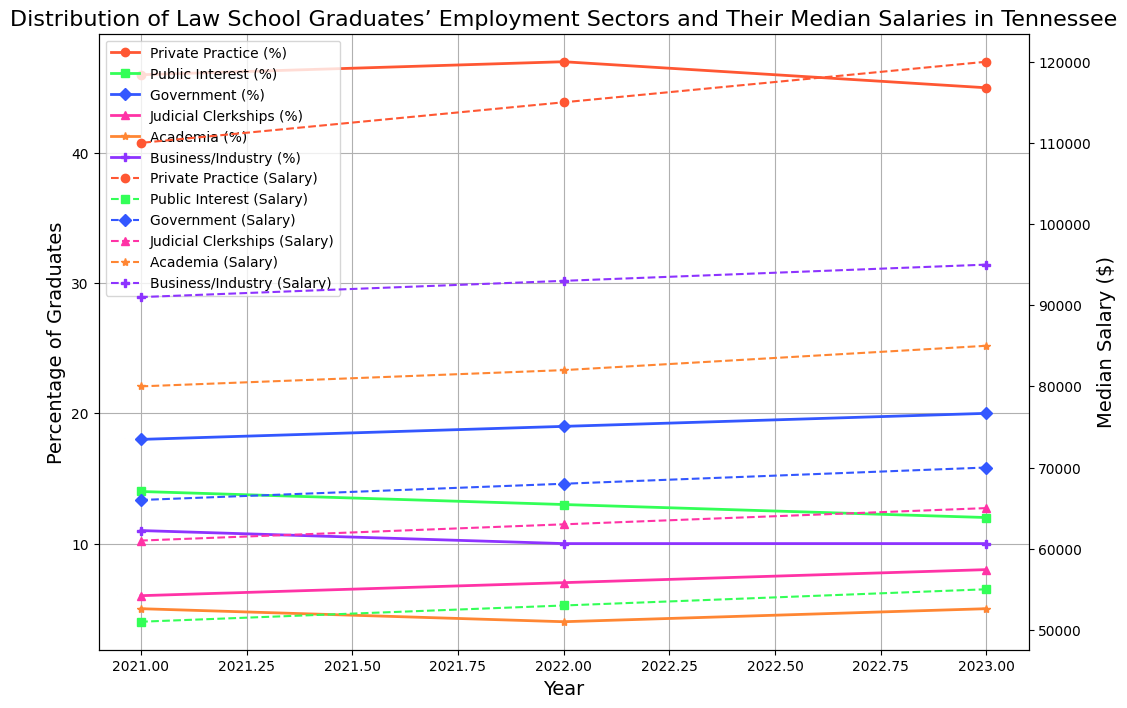Which employment sector had the highest median salary in 2023? By visually analyzing the plot, we can see that 'Private Practice' had the highest median salary line, which was the highest among all sectors in 2023.
Answer: Private Practice How did the percentage of graduates in Private Practice change from 2021 to 2023? We observe the solid line for 'Private Practice'. In 2021, it was at about 46%, and in 2023, it decreased slightly to 45%. Therefore, there is a 1% decrease.
Answer: Decreased by 1% What is the difference between the median salaries of graduates in the Private Practice and Public Interest sectors in 2023? The dashed line for 'Private Practice' indicates a median salary of $120,000 in 2023, while 'Public Interest' indicates $55,000. The difference is $120,000 - $55,000 = $65,000.
Answer: $65,000 Between which years did the median salary for Judicial Clerkships see the most significant increase? Looking at the dashed line for 'Judicial Clerkships', the salary increased from $61,000 in 2021 to $63,000 in 2022 and then to $65,000 in 2023. The largest increase is between 2022 and 2023, with an increase of $2,000.
Answer: Between 2022 and 2023 Which sector had the lowest percentage of graduates continuously across all three years? By observing the solid lines across all years, 'Academia' has the lowest percentage (never exceeding 5%) across the years 2021, 2022, and 2023.
Answer: Academia In 2022, did more graduates go to Business/Industry or Judicial Clerkships? We can compare the solid lines for 'Business/Industry' and 'Judicial Clerkships' in 2022. The percentage for Business/Industry is 10% and for Judicial Clerkships is 7%. Therefore, more graduates went into Business/Industry.
Answer: Business/Industry What is the average median salary for graduates in Government across the three years? We can take the median salaries for Government from the dashed line: $66,000 for 2021, $68,000 for 2022, and $70,000 for 2023. The average is $(66,000 + 68,000 + 70,000) / 3 = $68,000.
Answer: $68,000 Which sector showed the largest fluctuation in the percentage of graduates between 2021 and 2023? By comparing the solid lines for changes, 'Government' shows a relatively larger change, going from 18% in 2021 to 20% in 2023, but 'Judicial Clerkships' increased from 6% in 2021 to 8% in 2023. Clearly, 'Public Interest' also fluctuates from 14% to 12%.
Answer: Public Interest In which year did graduates in Academia have the highest median salary? We focus on the dashed line for 'Academia'. The highest median salary occurred in the year 2023, which was $85,000 compared to $82,000 in 2022 and $80,000 in 2021.
Answer: 2023 